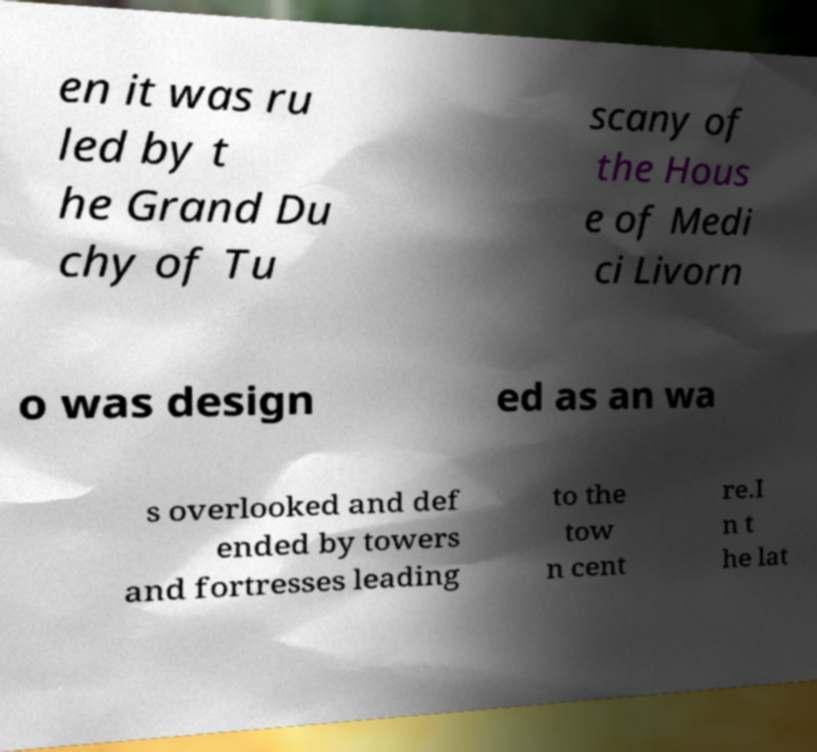For documentation purposes, I need the text within this image transcribed. Could you provide that? en it was ru led by t he Grand Du chy of Tu scany of the Hous e of Medi ci Livorn o was design ed as an wa s overlooked and def ended by towers and fortresses leading to the tow n cent re.I n t he lat 